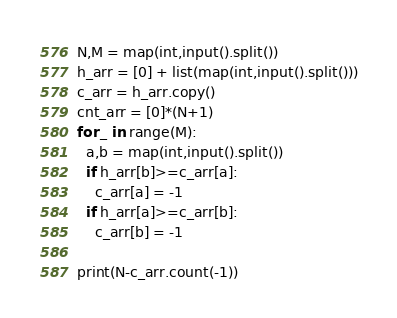Convert code to text. <code><loc_0><loc_0><loc_500><loc_500><_Python_>N,M = map(int,input().split())
h_arr = [0] + list(map(int,input().split()))
c_arr = h_arr.copy()
cnt_arr = [0]*(N+1)
for _ in range(M):
  a,b = map(int,input().split())
  if h_arr[b]>=c_arr[a]:
    c_arr[a] = -1
  if h_arr[a]>=c_arr[b]:
    c_arr[b] = -1

print(N-c_arr.count(-1))</code> 